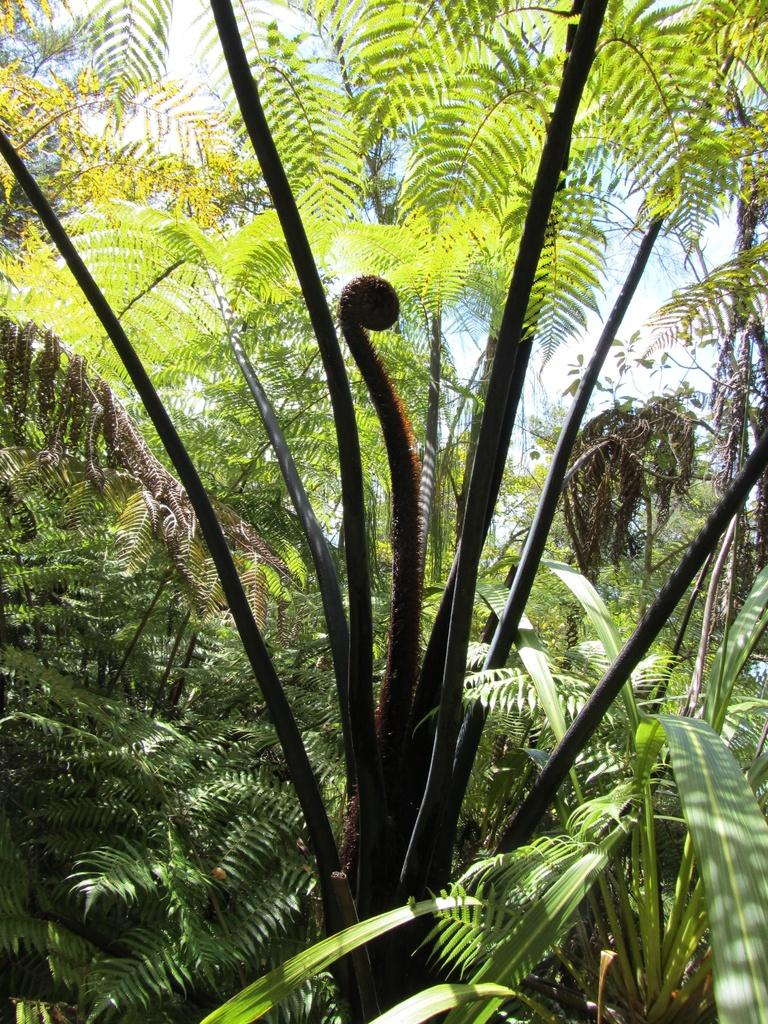What type of vegetation can be seen in the image? There are trees in the image. What can be seen in the sky in the background of the image? Clouds are visible in the background of the image. What else is visible in the background of the image? The sky is visible in the background of the image. What type of art can be seen hanging from the trees in the image? There is no art visible hanging from the trees in the image; only trees, clouds, and the sky are present. 